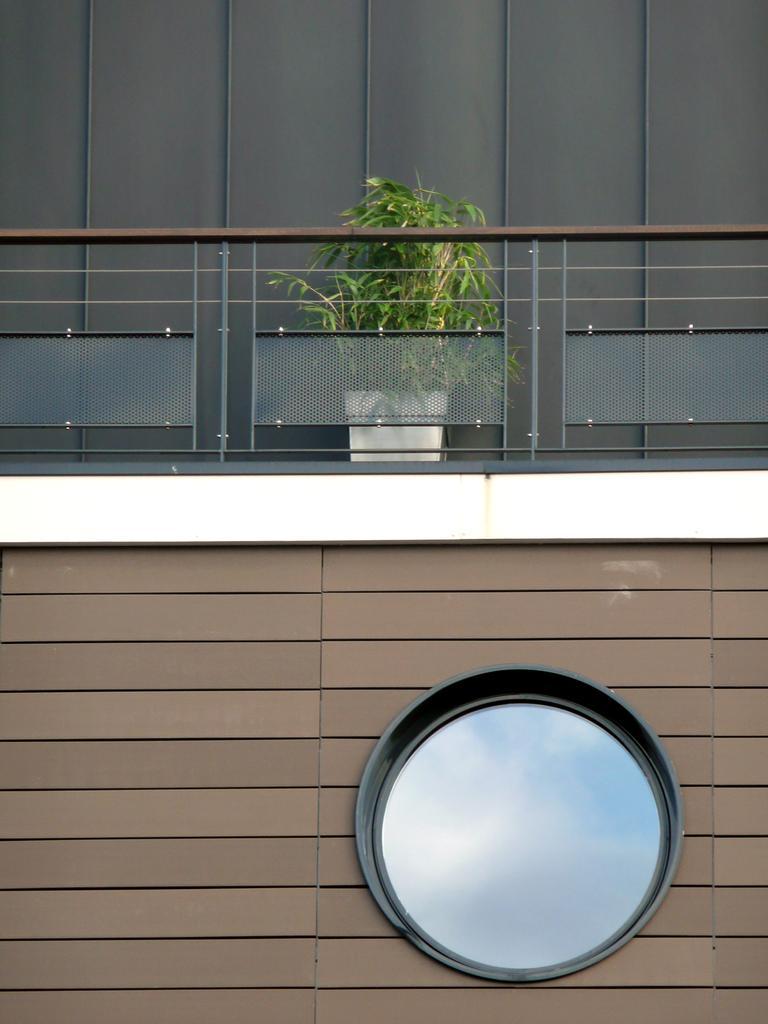Please provide a concise description of this image. In the foreground of this image, there is a wall and a circular structure on it. On the top, there is railing, behind it, there is a plant and a black wall. 